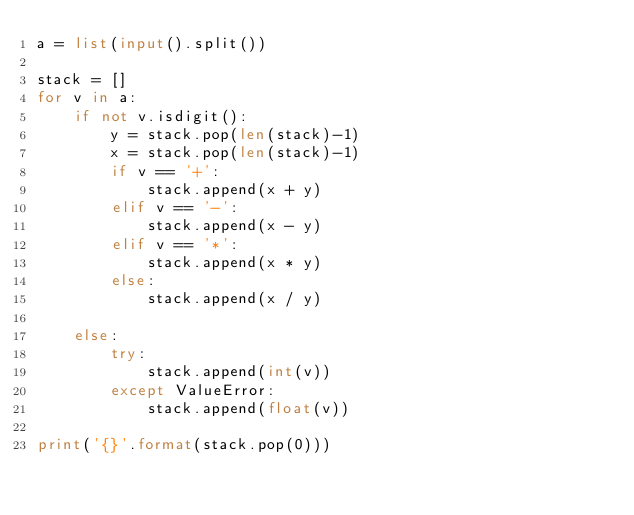<code> <loc_0><loc_0><loc_500><loc_500><_Python_>a = list(input().split())

stack = []
for v in a:
    if not v.isdigit():
        y = stack.pop(len(stack)-1)
        x = stack.pop(len(stack)-1)
        if v == '+':
            stack.append(x + y)
        elif v == '-':
            stack.append(x - y)
        elif v == '*':
            stack.append(x * y)
        else:
            stack.append(x / y)

    else:
        try:
            stack.append(int(v))
        except ValueError:
            stack.append(float(v))

print('{}'.format(stack.pop(0)))

</code> 